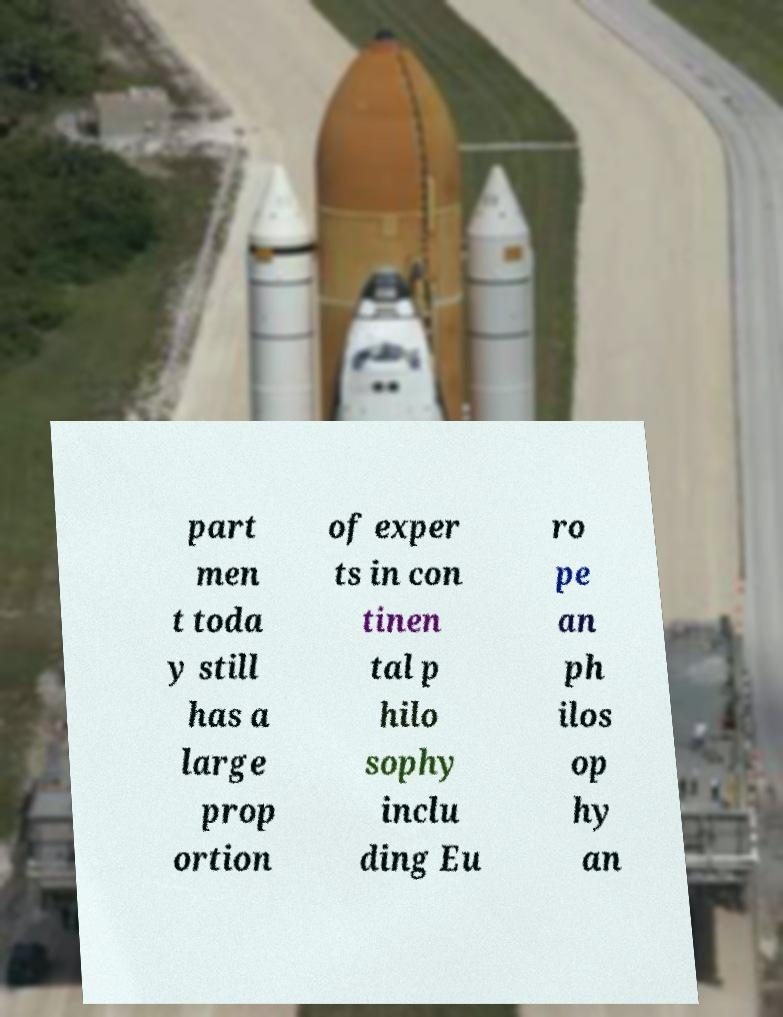Could you extract and type out the text from this image? part men t toda y still has a large prop ortion of exper ts in con tinen tal p hilo sophy inclu ding Eu ro pe an ph ilos op hy an 